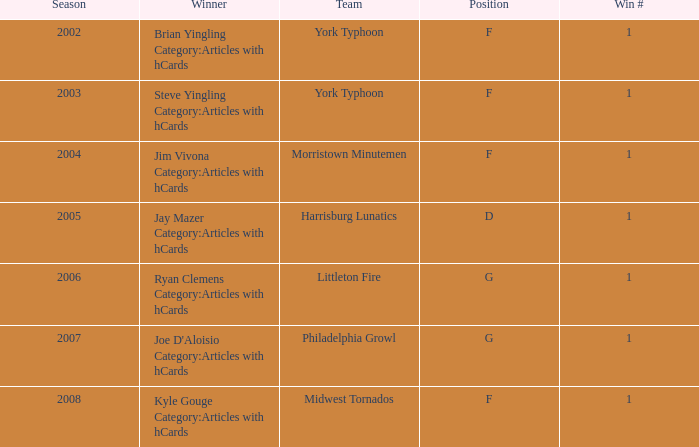Who claimed the championship title during the 2008 season? Kyle Gouge Category:Articles with hCards. 